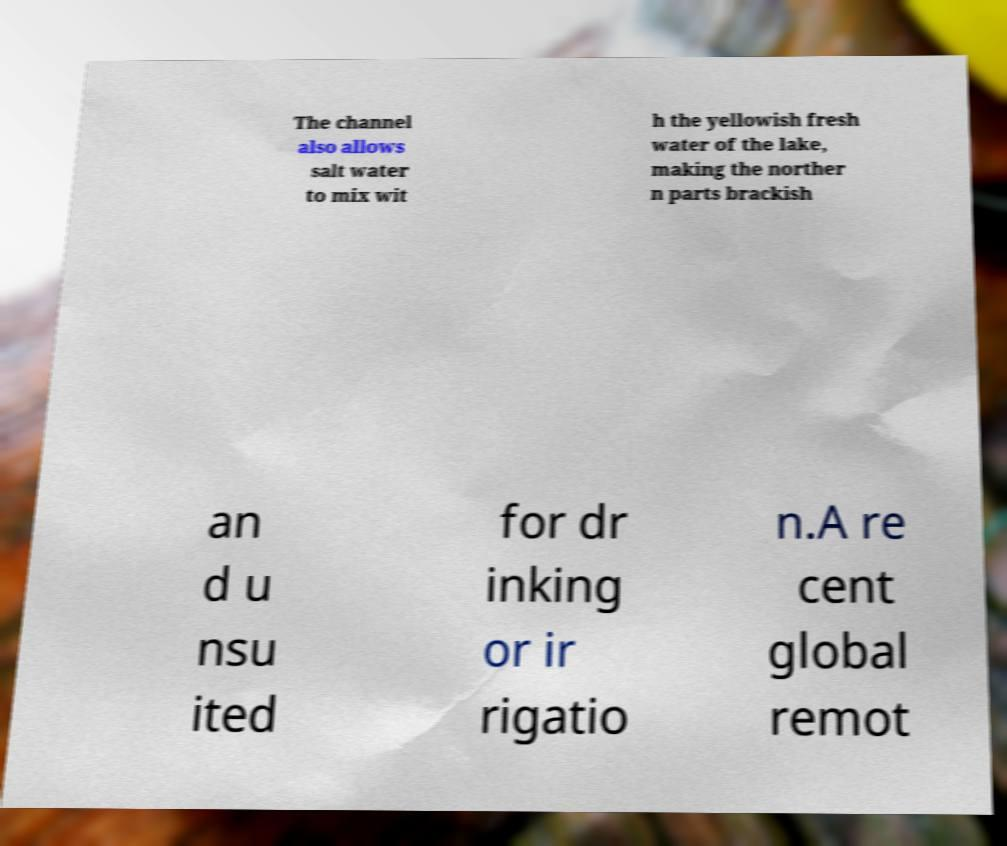Can you read and provide the text displayed in the image?This photo seems to have some interesting text. Can you extract and type it out for me? The channel also allows salt water to mix wit h the yellowish fresh water of the lake, making the norther n parts brackish an d u nsu ited for dr inking or ir rigatio n.A re cent global remot 